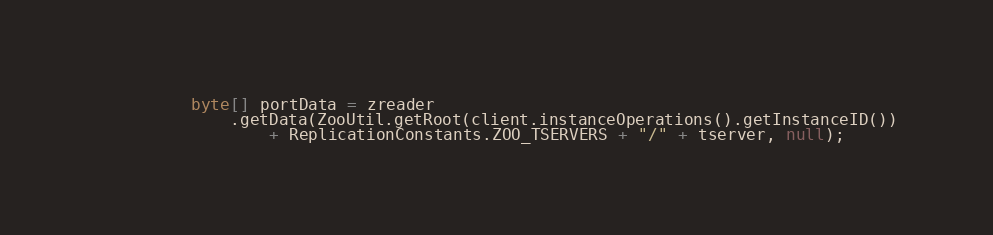Convert code to text. <code><loc_0><loc_0><loc_500><loc_500><_Java_>          byte[] portData = zreader
              .getData(ZooUtil.getRoot(client.instanceOperations().getInstanceID())
                  + ReplicationConstants.ZOO_TSERVERS + "/" + tserver, null);</code> 